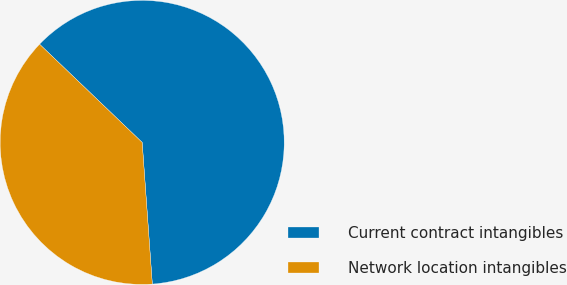Convert chart to OTSL. <chart><loc_0><loc_0><loc_500><loc_500><pie_chart><fcel>Current contract intangibles<fcel>Network location intangibles<nl><fcel>61.71%<fcel>38.29%<nl></chart> 